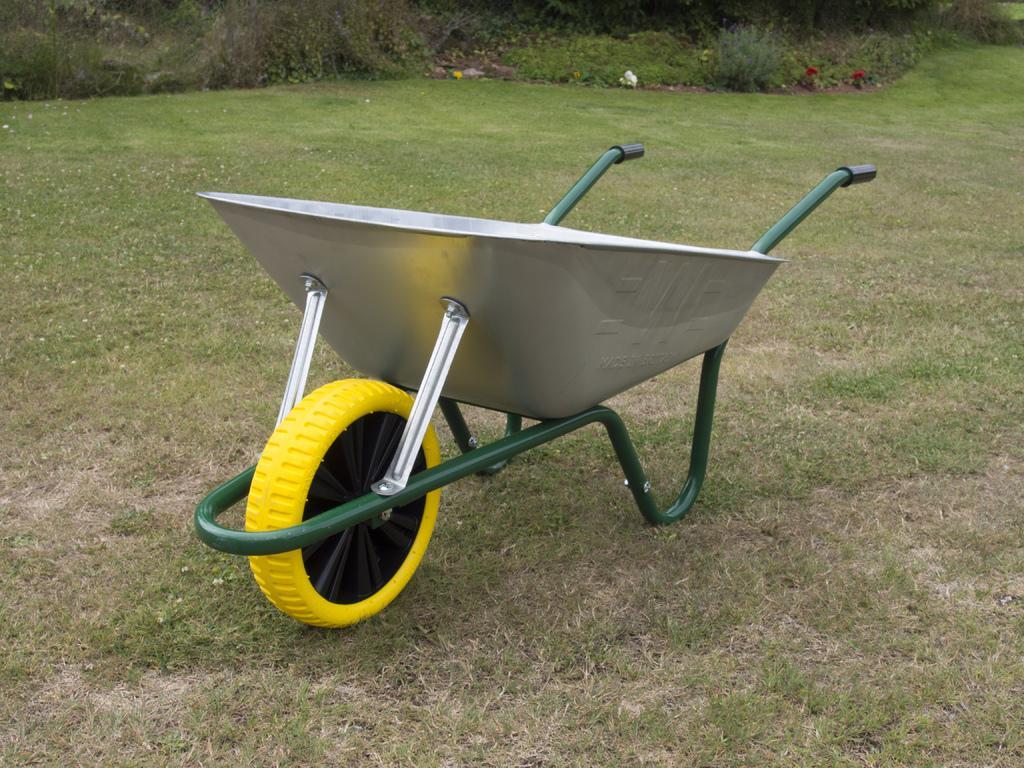Could you give a brief overview of what you see in this image? In this image I see a trolley over here which is of silver, yellow, black and green in color and I see the green grass. In the background I see the plants. 